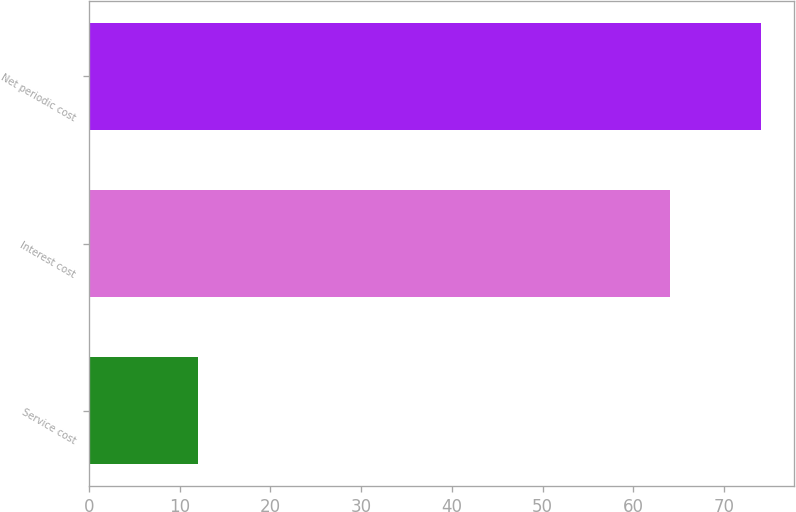Convert chart to OTSL. <chart><loc_0><loc_0><loc_500><loc_500><bar_chart><fcel>Service cost<fcel>Interest cost<fcel>Net periodic cost<nl><fcel>12<fcel>64<fcel>74<nl></chart> 